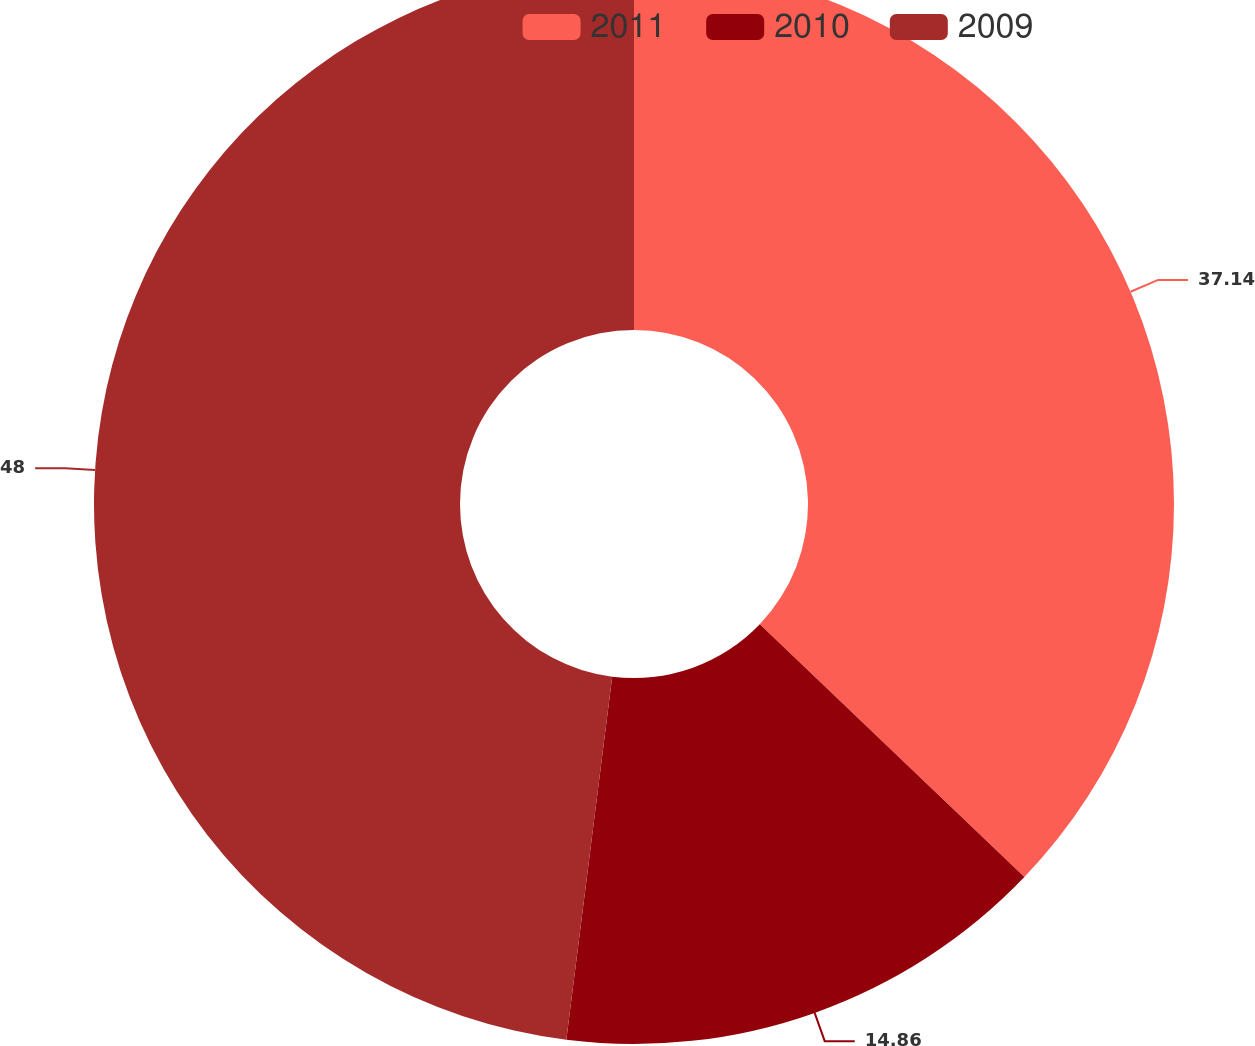<chart> <loc_0><loc_0><loc_500><loc_500><pie_chart><fcel>2011<fcel>2010<fcel>2009<nl><fcel>37.14%<fcel>14.86%<fcel>48.0%<nl></chart> 